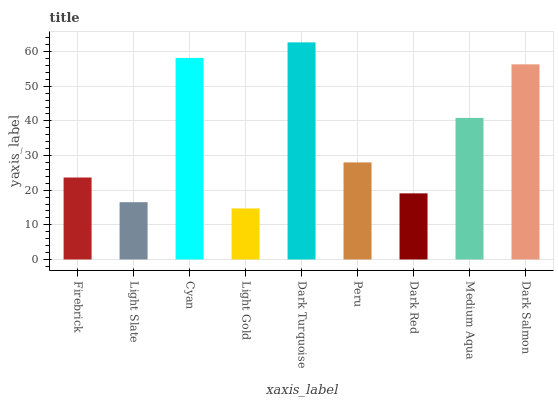Is Light Gold the minimum?
Answer yes or no. Yes. Is Dark Turquoise the maximum?
Answer yes or no. Yes. Is Light Slate the minimum?
Answer yes or no. No. Is Light Slate the maximum?
Answer yes or no. No. Is Firebrick greater than Light Slate?
Answer yes or no. Yes. Is Light Slate less than Firebrick?
Answer yes or no. Yes. Is Light Slate greater than Firebrick?
Answer yes or no. No. Is Firebrick less than Light Slate?
Answer yes or no. No. Is Peru the high median?
Answer yes or no. Yes. Is Peru the low median?
Answer yes or no. Yes. Is Medium Aqua the high median?
Answer yes or no. No. Is Dark Red the low median?
Answer yes or no. No. 